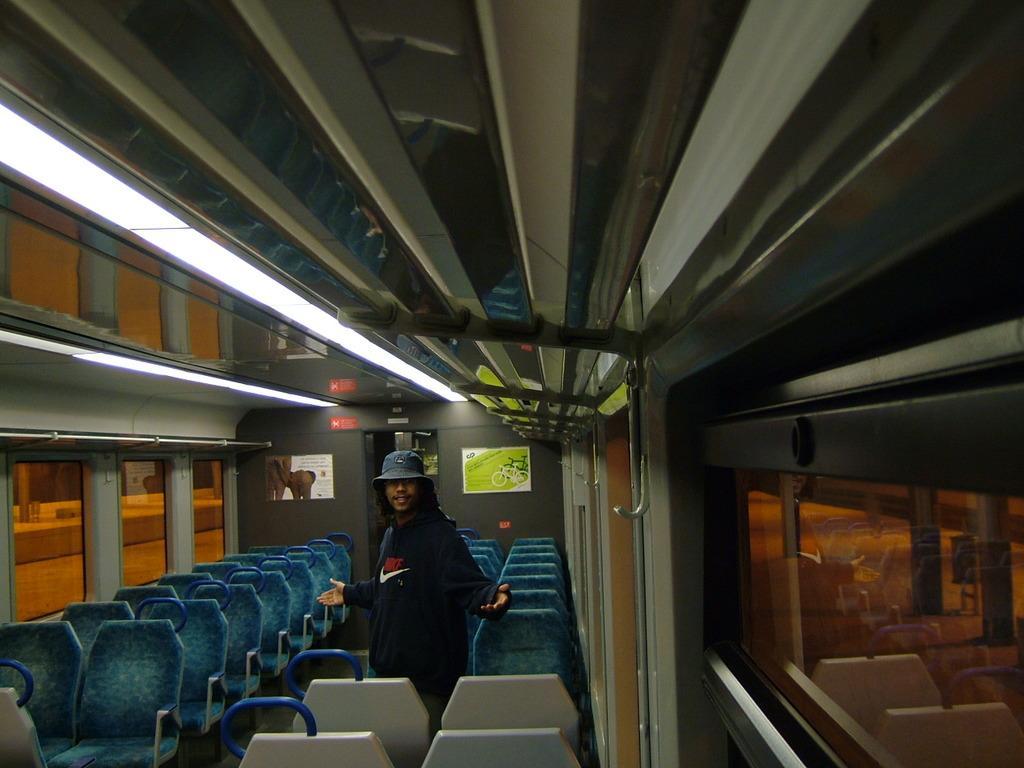How would you summarize this image in a sentence or two? This picture is an inside view of a vehicle. In the center of the image we can see a man is standing and wearing dress, hat. In the background of the image we can see the seats, posters, wall, glass windows. At the top of the image we can see the lights and roof. Through windows we can see the platform. 